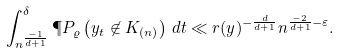<formula> <loc_0><loc_0><loc_500><loc_500>\int _ { n ^ { \frac { - 1 } { d + 1 } } } ^ { \delta } \P P _ { \varrho } \left ( y _ { t } \not \in K _ { ( n ) } \right ) \, d t \ll r ( y ) ^ { - \frac { d } { d + 1 } } n ^ { \frac { - 2 } { d + 1 } - \varepsilon } .</formula> 